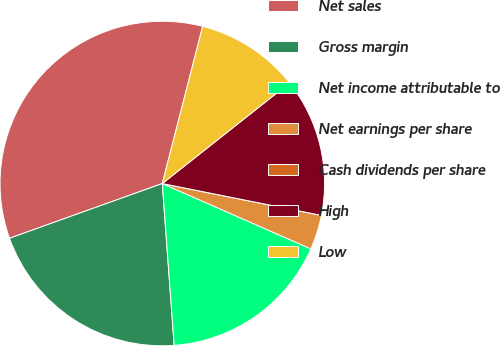Convert chart. <chart><loc_0><loc_0><loc_500><loc_500><pie_chart><fcel>Net sales<fcel>Gross margin<fcel>Net income attributable to<fcel>Net earnings per share<fcel>Cash dividends per share<fcel>High<fcel>Low<nl><fcel>34.48%<fcel>20.69%<fcel>17.24%<fcel>3.45%<fcel>0.0%<fcel>13.79%<fcel>10.35%<nl></chart> 